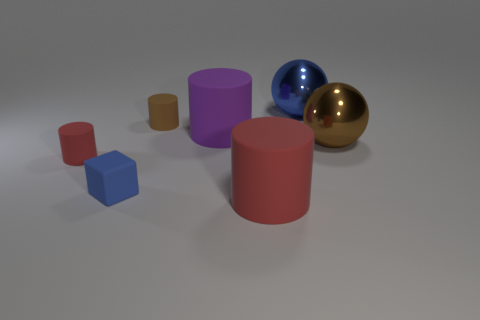The big metal sphere to the right of the metallic sphere behind the big matte cylinder that is behind the rubber block is what color? The large sphere in question, positioned to the right of a smaller, blue metallic sphere and located behind a matte cylinder, is gold in color. Its polished surface gives it a reflective characteristic that distinguishes it from the other objects in the image. 